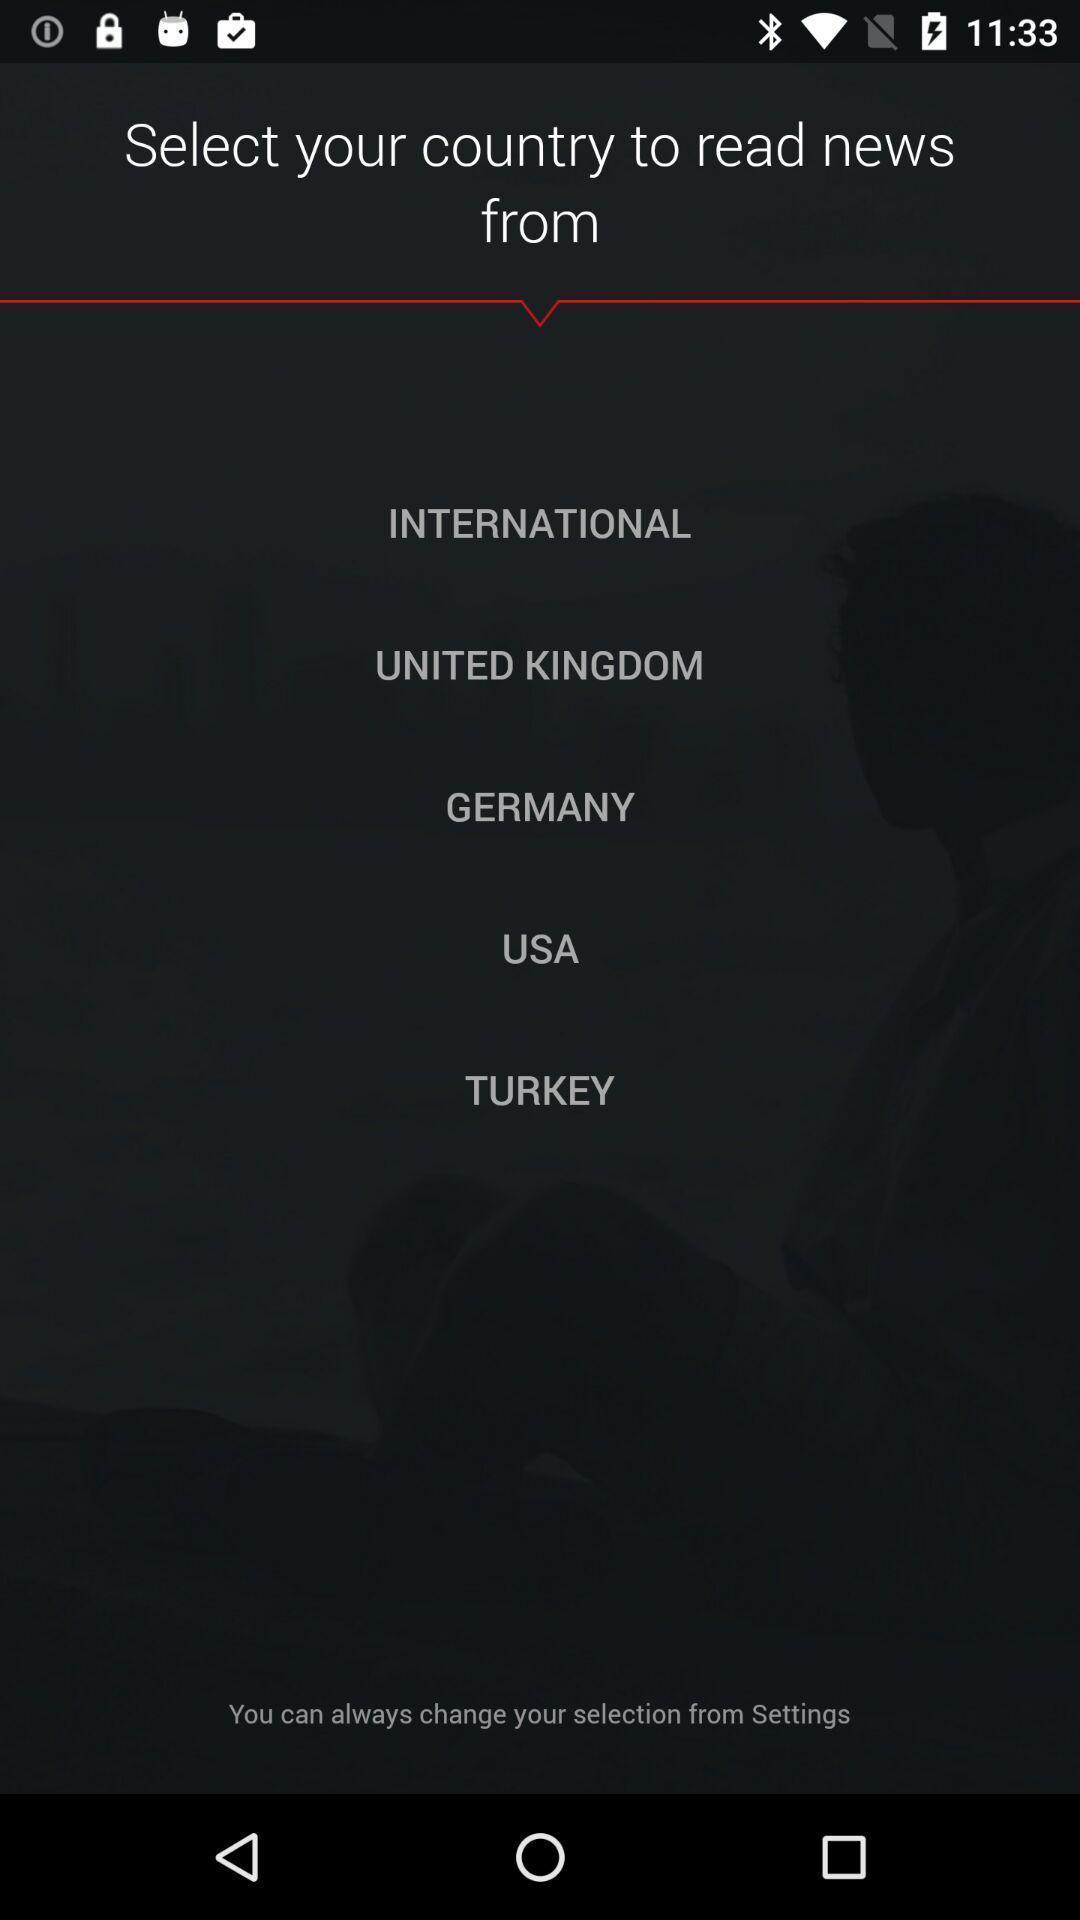Provide a detailed account of this screenshot. Page showing to select your country. 